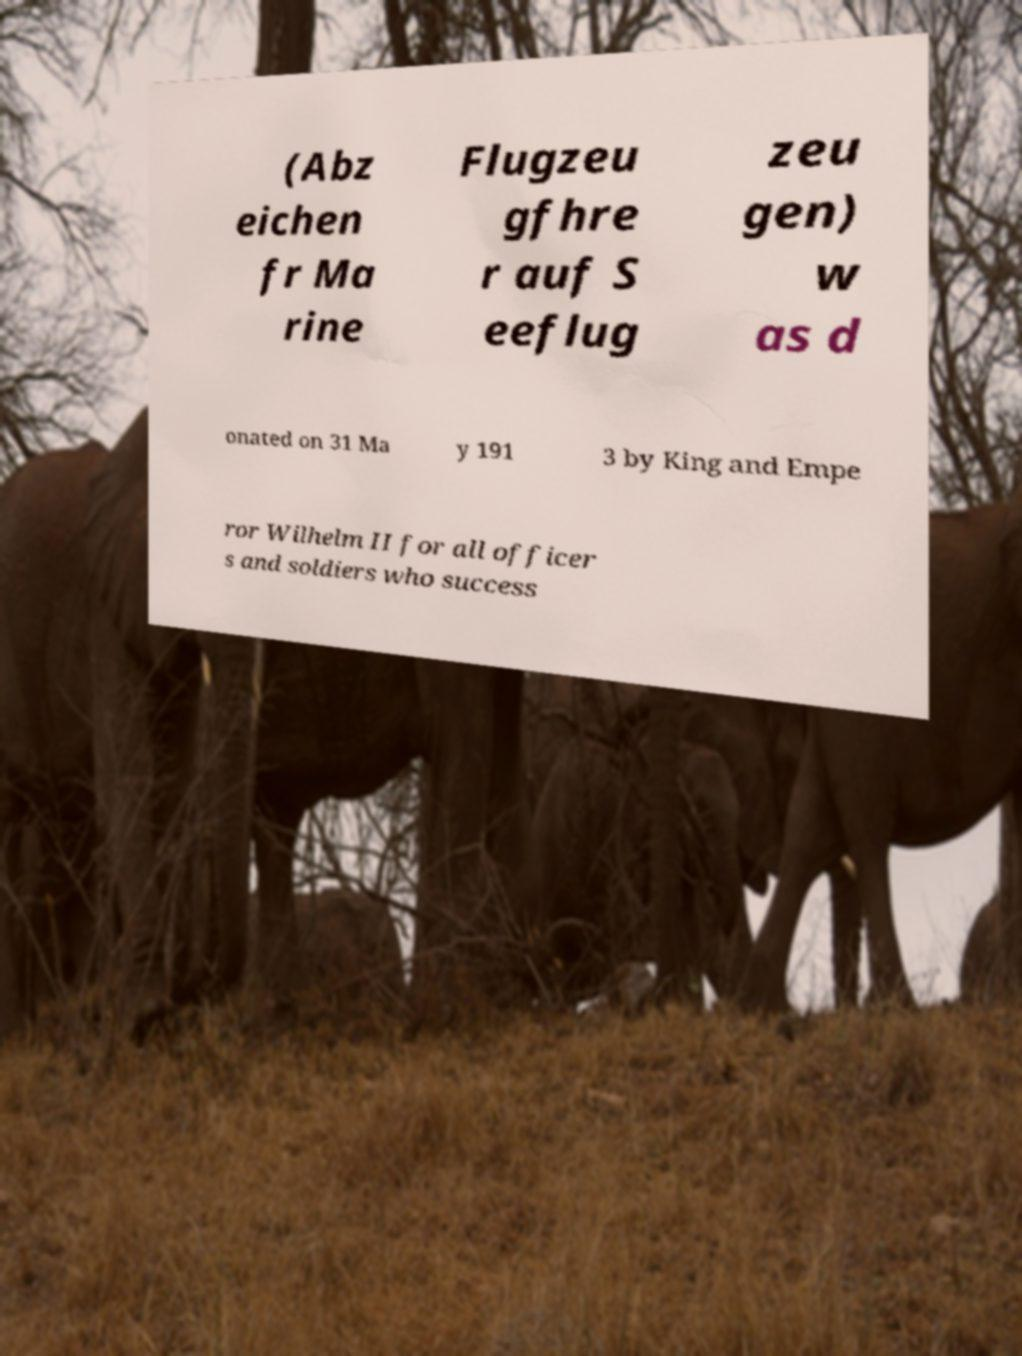Please read and relay the text visible in this image. What does it say? (Abz eichen fr Ma rine Flugzeu gfhre r auf S eeflug zeu gen) w as d onated on 31 Ma y 191 3 by King and Empe ror Wilhelm II for all officer s and soldiers who success 